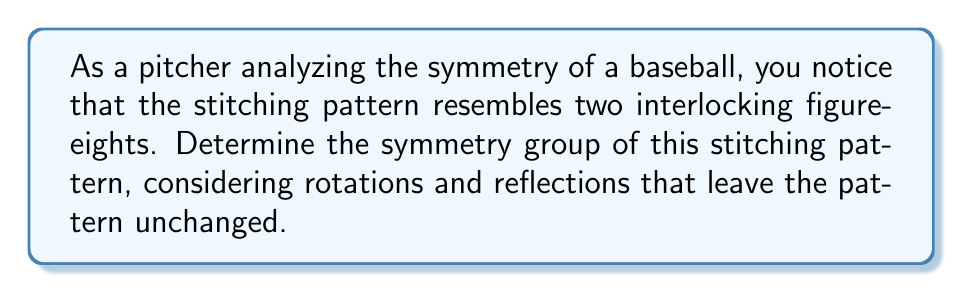What is the answer to this math problem? To determine the symmetry group of the baseball's stitching pattern, we'll follow these steps:

1) Identify the symmetries:
   a) Rotational symmetry: The stitching pattern has 2-fold rotational symmetry about three perpendicular axes:
      - Through the center of the figure-eights (pole-to-pole)
      - Through the intersection of the figure-eights (side-to-side)
      - Perpendicular to both of the above (front-to-back)
   b) Reflection symmetry: The pattern has three planes of reflection symmetry, each containing two of the rotational axes.

2) Count the symmetry operations:
   - Identity: 1
   - 180° rotations: 3 (one about each axis)
   - Reflections: 3 (one across each plane)
   Total: 7 symmetry operations

3) Identify the group:
   The group with these symmetries is isomorphic to $D_2$, also known as the Klein four-group $V_4$, with the addition of reflections. This group is called $D_{2h}$ in Schönflies notation or $mmm$ in Hermann–Mauguin notation.

4) Represent the group formally:
   $G = \{e, R_x, R_y, R_z, \sigma_{xy}, \sigma_{yz}, \sigma_{xz}\}$
   Where $e$ is the identity, $R_i$ are 180° rotations about axis $i$, and $\sigma_{ij}$ are reflections in the plane containing axes $i$ and $j$.

5) Verify group properties:
   - Closure: All combinations of these operations result in operations within the group.
   - Associativity: Holds for all symmetry operations.
   - Identity: The identity operation $e$ exists.
   - Inverse: Each operation is its own inverse.

Therefore, the symmetry group of the baseball's stitching pattern is $D_{2h}$, which is of order 8 and is isomorphic to the direct product of three cyclic groups of order 2: $C_2 \times C_2 \times C_2$.
Answer: $D_{2h}$ 